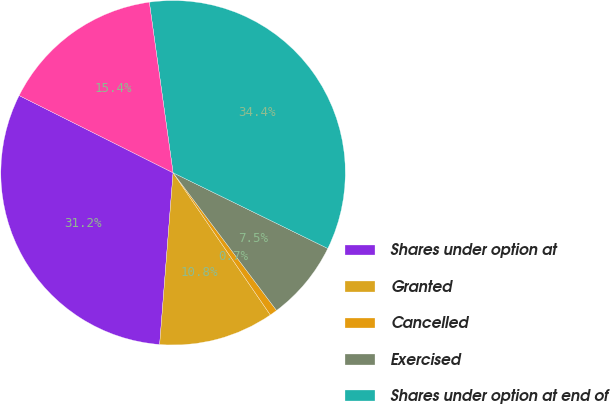Convert chart to OTSL. <chart><loc_0><loc_0><loc_500><loc_500><pie_chart><fcel>Shares under option at<fcel>Granted<fcel>Cancelled<fcel>Exercised<fcel>Shares under option at end of<fcel>Exercisable at end of year<nl><fcel>31.16%<fcel>10.79%<fcel>0.71%<fcel>7.5%<fcel>34.45%<fcel>15.4%<nl></chart> 